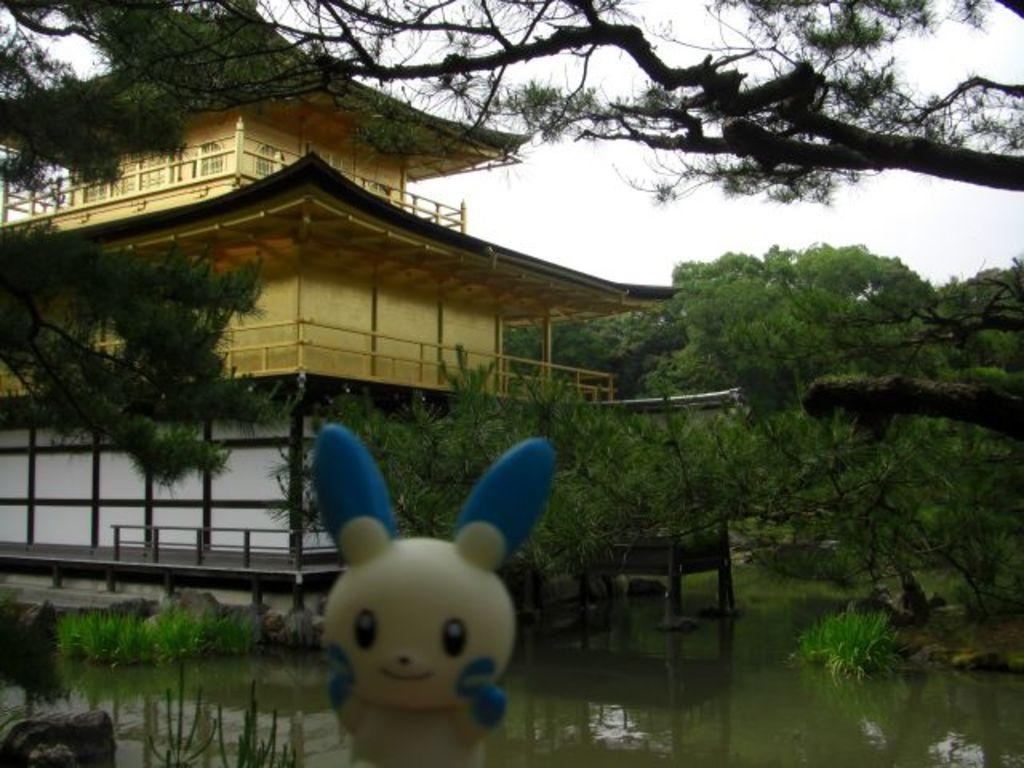What object can be seen in the image that is typically used for play or entertainment? There is a toy in the image. What natural element is visible in the image? Water is visible in the image. What type of geological feature is present in the image? Rocks are present in the image. What type of vegetation is visible in the image? Plants and trees are visible in the image. What type of man-made structure is visible in the image? There is a building in the image. What part of the natural environment is visible in the background of the image? The sky is visible in the background of the image. What type of cheese is being used to decorate the building in the image? There is no cheese present in the image; it features a toy, water, rocks, plants, trees, and a building. What type of curtain is hanging from the trees in the image? There are no curtains present in the image; it features a toy, water, rocks, plants, trees, and a building. 